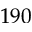<formula> <loc_0><loc_0><loc_500><loc_500>1 9 0</formula> 